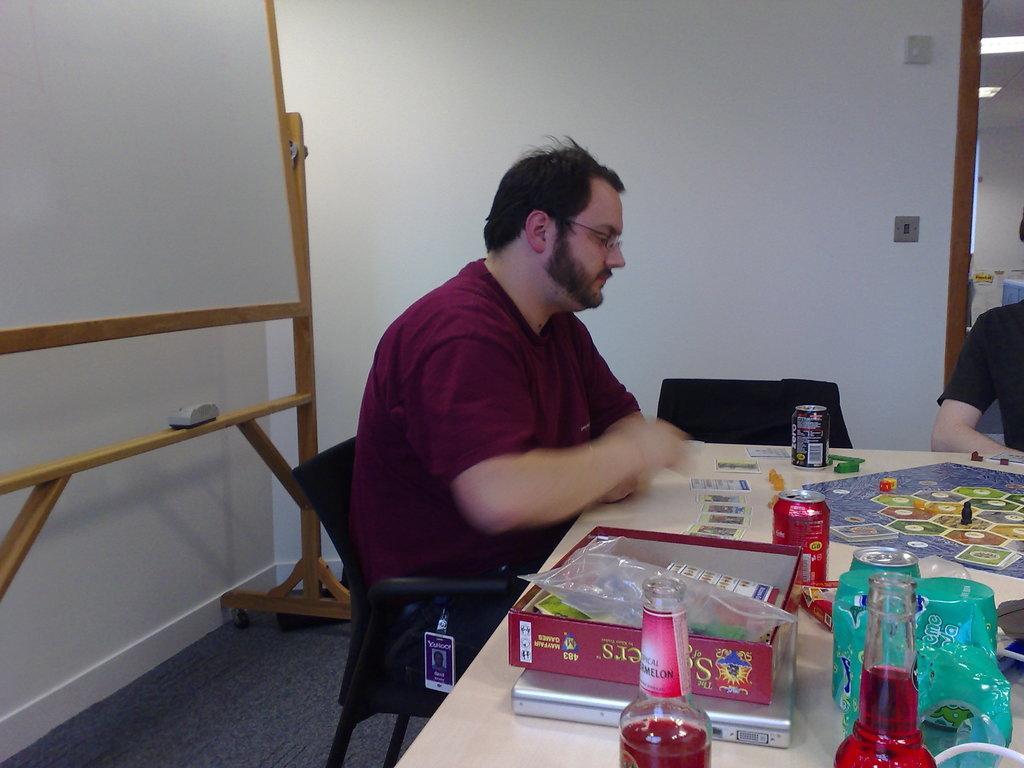In one or two sentences, can you explain what this image depicts? On the background we can see wall. This is a whiteboard. Here on the wooden stand we can see a duster. Here we can see men sitting on chairs in front of a table and on the table we can see box, bottles, tins , a game board , laptop and playing cards. 